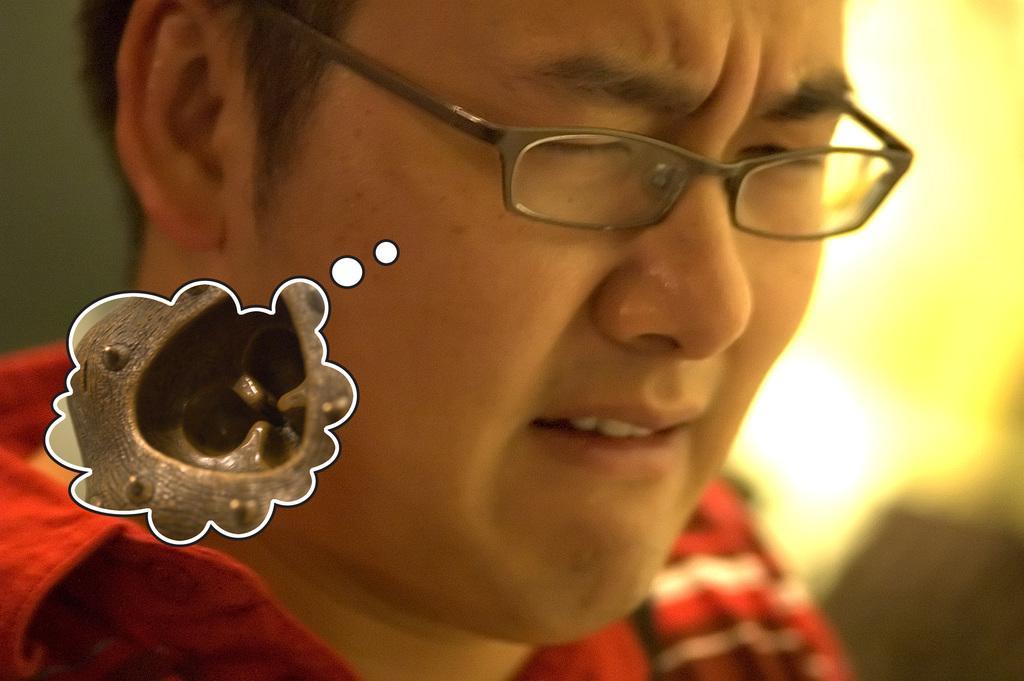How would you summarize this image in a sentence or two? This is the picture of a person in spectacles and to the side there is a cloud shape thing. 